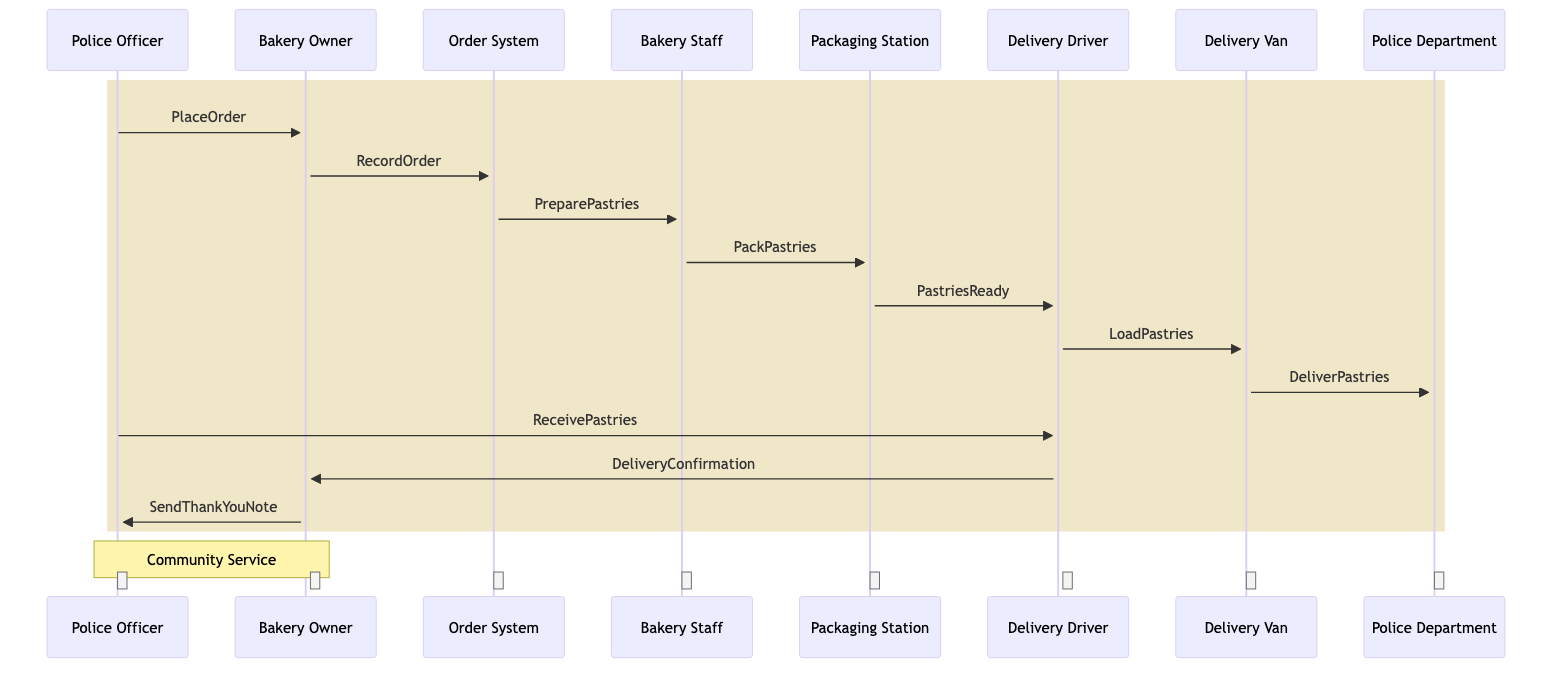What's the first action taken in the sequence? The first action is the Police Officer placing an order to the Bakery Owner, as indicated by the arrow from Police Officer to Bakery Owner labeled "PlaceOrder."
Answer: PlaceOrder How many main participants are involved in the sequence? The diagram lists seven participants: Police Officer, Bakery Owner, Order System, Bakery Staff, Packaging Station, Delivery Driver, Delivery Van, and Police Department, totaling seven participants.
Answer: Seven What message does the Bakery Owner send to the Order System? The message sent from the Bakery Owner to the Order System is "RecordOrder," as shown by the directed arrow indicating this interaction.
Answer: RecordOrder What is the last action completed by the Delivery Driver? The last action completed by the Delivery Driver is sending the "DeliveryConfirmation" back to the Bakery Owner, as shown in the diagram.
Answer: DeliveryConfirmation What is the relationship between the Police Officer and the Delivery Driver after the pastries are delivered? After the pastries are delivered, the relationship involves the Police Officer receiving the pastries, as indicated by the arrow labeled "ReceivePastries."
Answer: ReceivePastries How does the Bakery Owner express gratitude to the Police Officer? The Bakery Owner expresses gratitude by sending a "Thank You Note" to the Police Officer, as indicated by the directed message from Bakery Owner to Police Officer.
Answer: SendThankYouNote What happens immediately after the Police Officer places the order? Immediately after the Police Officer places the order, the Bakery Owner records the order in the Order System, as shown by the sequence flow following the initial action.
Answer: RecordOrder Which actor is responsible for preparing the pastries? The Bakery Staff is responsible for preparing the pastries, as indicated by the message flow from the Order System to the Bakery Staff labeled "PreparePastries."
Answer: Bakery Staff What is the purpose of the 'note' section in the diagram? The purpose of the 'note' section is to emphasize the theme of community service shared between the Bakery Owner and the Police Officer, represented collectively over them.
Answer: Community Service 